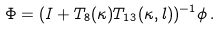<formula> <loc_0><loc_0><loc_500><loc_500>\Phi = ( I + T _ { 8 } ( \kappa ) T _ { 1 3 } ( \kappa , l ) ) ^ { - 1 } \phi \, .</formula> 